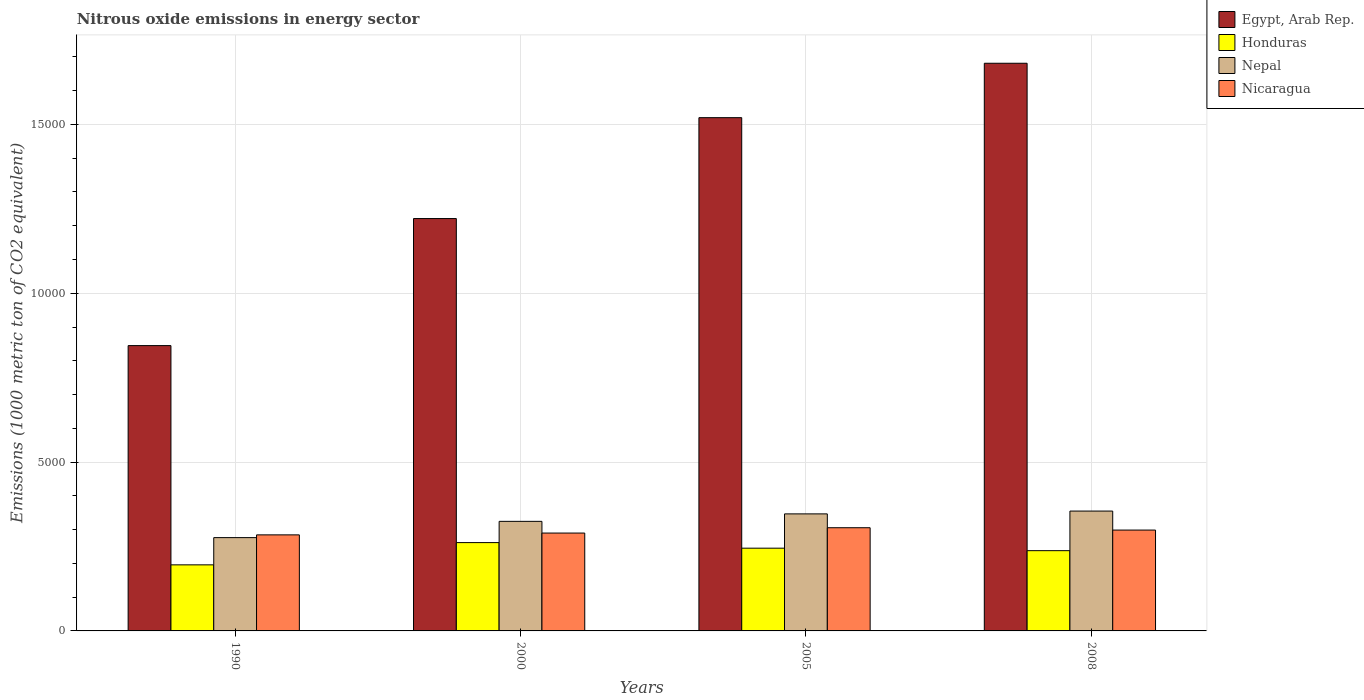Are the number of bars per tick equal to the number of legend labels?
Make the answer very short. Yes. Are the number of bars on each tick of the X-axis equal?
Offer a terse response. Yes. How many bars are there on the 3rd tick from the left?
Your response must be concise. 4. How many bars are there on the 1st tick from the right?
Offer a terse response. 4. What is the label of the 3rd group of bars from the left?
Make the answer very short. 2005. What is the amount of nitrous oxide emitted in Honduras in 2008?
Provide a short and direct response. 2376.9. Across all years, what is the maximum amount of nitrous oxide emitted in Nicaragua?
Your answer should be very brief. 3056.1. Across all years, what is the minimum amount of nitrous oxide emitted in Nicaragua?
Your response must be concise. 2844.7. In which year was the amount of nitrous oxide emitted in Egypt, Arab Rep. maximum?
Your answer should be compact. 2008. In which year was the amount of nitrous oxide emitted in Nicaragua minimum?
Provide a short and direct response. 1990. What is the total amount of nitrous oxide emitted in Nepal in the graph?
Offer a very short reply. 1.30e+04. What is the difference between the amount of nitrous oxide emitted in Honduras in 1990 and that in 2000?
Provide a succinct answer. -658.9. What is the difference between the amount of nitrous oxide emitted in Honduras in 2000 and the amount of nitrous oxide emitted in Nepal in 2008?
Give a very brief answer. -934. What is the average amount of nitrous oxide emitted in Honduras per year?
Your answer should be compact. 2349.78. In the year 2005, what is the difference between the amount of nitrous oxide emitted in Honduras and amount of nitrous oxide emitted in Nicaragua?
Provide a succinct answer. -605.8. In how many years, is the amount of nitrous oxide emitted in Honduras greater than 14000 1000 metric ton?
Offer a terse response. 0. What is the ratio of the amount of nitrous oxide emitted in Egypt, Arab Rep. in 2000 to that in 2005?
Provide a short and direct response. 0.8. Is the amount of nitrous oxide emitted in Honduras in 2000 less than that in 2005?
Give a very brief answer. No. What is the difference between the highest and the second highest amount of nitrous oxide emitted in Honduras?
Your answer should be compact. 165.1. What is the difference between the highest and the lowest amount of nitrous oxide emitted in Honduras?
Make the answer very short. 658.9. In how many years, is the amount of nitrous oxide emitted in Nepal greater than the average amount of nitrous oxide emitted in Nepal taken over all years?
Your answer should be very brief. 2. Is the sum of the amount of nitrous oxide emitted in Nepal in 1990 and 2000 greater than the maximum amount of nitrous oxide emitted in Nicaragua across all years?
Your answer should be very brief. Yes. What does the 3rd bar from the left in 1990 represents?
Provide a short and direct response. Nepal. What does the 4th bar from the right in 2008 represents?
Your answer should be compact. Egypt, Arab Rep. Is it the case that in every year, the sum of the amount of nitrous oxide emitted in Nicaragua and amount of nitrous oxide emitted in Egypt, Arab Rep. is greater than the amount of nitrous oxide emitted in Nepal?
Your response must be concise. Yes. Are all the bars in the graph horizontal?
Your response must be concise. No. How many years are there in the graph?
Your response must be concise. 4. What is the difference between two consecutive major ticks on the Y-axis?
Make the answer very short. 5000. Are the values on the major ticks of Y-axis written in scientific E-notation?
Make the answer very short. No. Where does the legend appear in the graph?
Make the answer very short. Top right. How many legend labels are there?
Offer a terse response. 4. What is the title of the graph?
Keep it short and to the point. Nitrous oxide emissions in energy sector. What is the label or title of the X-axis?
Keep it short and to the point. Years. What is the label or title of the Y-axis?
Provide a short and direct response. Emissions (1000 metric ton of CO2 equivalent). What is the Emissions (1000 metric ton of CO2 equivalent) in Egypt, Arab Rep. in 1990?
Your answer should be very brief. 8449.9. What is the Emissions (1000 metric ton of CO2 equivalent) in Honduras in 1990?
Your answer should be compact. 1956.5. What is the Emissions (1000 metric ton of CO2 equivalent) in Nepal in 1990?
Ensure brevity in your answer.  2763. What is the Emissions (1000 metric ton of CO2 equivalent) of Nicaragua in 1990?
Ensure brevity in your answer.  2844.7. What is the Emissions (1000 metric ton of CO2 equivalent) of Egypt, Arab Rep. in 2000?
Provide a succinct answer. 1.22e+04. What is the Emissions (1000 metric ton of CO2 equivalent) in Honduras in 2000?
Give a very brief answer. 2615.4. What is the Emissions (1000 metric ton of CO2 equivalent) of Nepal in 2000?
Make the answer very short. 3244.8. What is the Emissions (1000 metric ton of CO2 equivalent) in Nicaragua in 2000?
Provide a succinct answer. 2898.2. What is the Emissions (1000 metric ton of CO2 equivalent) in Egypt, Arab Rep. in 2005?
Your answer should be compact. 1.52e+04. What is the Emissions (1000 metric ton of CO2 equivalent) of Honduras in 2005?
Offer a terse response. 2450.3. What is the Emissions (1000 metric ton of CO2 equivalent) in Nepal in 2005?
Offer a terse response. 3466.2. What is the Emissions (1000 metric ton of CO2 equivalent) in Nicaragua in 2005?
Your answer should be very brief. 3056.1. What is the Emissions (1000 metric ton of CO2 equivalent) in Egypt, Arab Rep. in 2008?
Your answer should be very brief. 1.68e+04. What is the Emissions (1000 metric ton of CO2 equivalent) of Honduras in 2008?
Ensure brevity in your answer.  2376.9. What is the Emissions (1000 metric ton of CO2 equivalent) of Nepal in 2008?
Ensure brevity in your answer.  3549.4. What is the Emissions (1000 metric ton of CO2 equivalent) in Nicaragua in 2008?
Ensure brevity in your answer.  2986.9. Across all years, what is the maximum Emissions (1000 metric ton of CO2 equivalent) of Egypt, Arab Rep.?
Your response must be concise. 1.68e+04. Across all years, what is the maximum Emissions (1000 metric ton of CO2 equivalent) in Honduras?
Give a very brief answer. 2615.4. Across all years, what is the maximum Emissions (1000 metric ton of CO2 equivalent) of Nepal?
Make the answer very short. 3549.4. Across all years, what is the maximum Emissions (1000 metric ton of CO2 equivalent) of Nicaragua?
Offer a very short reply. 3056.1. Across all years, what is the minimum Emissions (1000 metric ton of CO2 equivalent) in Egypt, Arab Rep.?
Ensure brevity in your answer.  8449.9. Across all years, what is the minimum Emissions (1000 metric ton of CO2 equivalent) in Honduras?
Your answer should be compact. 1956.5. Across all years, what is the minimum Emissions (1000 metric ton of CO2 equivalent) of Nepal?
Offer a very short reply. 2763. Across all years, what is the minimum Emissions (1000 metric ton of CO2 equivalent) in Nicaragua?
Offer a terse response. 2844.7. What is the total Emissions (1000 metric ton of CO2 equivalent) in Egypt, Arab Rep. in the graph?
Provide a succinct answer. 5.27e+04. What is the total Emissions (1000 metric ton of CO2 equivalent) of Honduras in the graph?
Give a very brief answer. 9399.1. What is the total Emissions (1000 metric ton of CO2 equivalent) in Nepal in the graph?
Offer a very short reply. 1.30e+04. What is the total Emissions (1000 metric ton of CO2 equivalent) in Nicaragua in the graph?
Give a very brief answer. 1.18e+04. What is the difference between the Emissions (1000 metric ton of CO2 equivalent) of Egypt, Arab Rep. in 1990 and that in 2000?
Provide a short and direct response. -3762.5. What is the difference between the Emissions (1000 metric ton of CO2 equivalent) of Honduras in 1990 and that in 2000?
Give a very brief answer. -658.9. What is the difference between the Emissions (1000 metric ton of CO2 equivalent) of Nepal in 1990 and that in 2000?
Your answer should be very brief. -481.8. What is the difference between the Emissions (1000 metric ton of CO2 equivalent) of Nicaragua in 1990 and that in 2000?
Give a very brief answer. -53.5. What is the difference between the Emissions (1000 metric ton of CO2 equivalent) in Egypt, Arab Rep. in 1990 and that in 2005?
Your response must be concise. -6750.1. What is the difference between the Emissions (1000 metric ton of CO2 equivalent) in Honduras in 1990 and that in 2005?
Keep it short and to the point. -493.8. What is the difference between the Emissions (1000 metric ton of CO2 equivalent) of Nepal in 1990 and that in 2005?
Offer a terse response. -703.2. What is the difference between the Emissions (1000 metric ton of CO2 equivalent) in Nicaragua in 1990 and that in 2005?
Keep it short and to the point. -211.4. What is the difference between the Emissions (1000 metric ton of CO2 equivalent) in Egypt, Arab Rep. in 1990 and that in 2008?
Provide a short and direct response. -8361.5. What is the difference between the Emissions (1000 metric ton of CO2 equivalent) in Honduras in 1990 and that in 2008?
Offer a terse response. -420.4. What is the difference between the Emissions (1000 metric ton of CO2 equivalent) of Nepal in 1990 and that in 2008?
Provide a succinct answer. -786.4. What is the difference between the Emissions (1000 metric ton of CO2 equivalent) in Nicaragua in 1990 and that in 2008?
Ensure brevity in your answer.  -142.2. What is the difference between the Emissions (1000 metric ton of CO2 equivalent) of Egypt, Arab Rep. in 2000 and that in 2005?
Give a very brief answer. -2987.6. What is the difference between the Emissions (1000 metric ton of CO2 equivalent) of Honduras in 2000 and that in 2005?
Give a very brief answer. 165.1. What is the difference between the Emissions (1000 metric ton of CO2 equivalent) in Nepal in 2000 and that in 2005?
Ensure brevity in your answer.  -221.4. What is the difference between the Emissions (1000 metric ton of CO2 equivalent) in Nicaragua in 2000 and that in 2005?
Your answer should be very brief. -157.9. What is the difference between the Emissions (1000 metric ton of CO2 equivalent) of Egypt, Arab Rep. in 2000 and that in 2008?
Offer a terse response. -4599. What is the difference between the Emissions (1000 metric ton of CO2 equivalent) in Honduras in 2000 and that in 2008?
Offer a very short reply. 238.5. What is the difference between the Emissions (1000 metric ton of CO2 equivalent) in Nepal in 2000 and that in 2008?
Your answer should be very brief. -304.6. What is the difference between the Emissions (1000 metric ton of CO2 equivalent) in Nicaragua in 2000 and that in 2008?
Offer a terse response. -88.7. What is the difference between the Emissions (1000 metric ton of CO2 equivalent) of Egypt, Arab Rep. in 2005 and that in 2008?
Provide a succinct answer. -1611.4. What is the difference between the Emissions (1000 metric ton of CO2 equivalent) in Honduras in 2005 and that in 2008?
Your answer should be compact. 73.4. What is the difference between the Emissions (1000 metric ton of CO2 equivalent) of Nepal in 2005 and that in 2008?
Offer a very short reply. -83.2. What is the difference between the Emissions (1000 metric ton of CO2 equivalent) of Nicaragua in 2005 and that in 2008?
Ensure brevity in your answer.  69.2. What is the difference between the Emissions (1000 metric ton of CO2 equivalent) of Egypt, Arab Rep. in 1990 and the Emissions (1000 metric ton of CO2 equivalent) of Honduras in 2000?
Keep it short and to the point. 5834.5. What is the difference between the Emissions (1000 metric ton of CO2 equivalent) of Egypt, Arab Rep. in 1990 and the Emissions (1000 metric ton of CO2 equivalent) of Nepal in 2000?
Make the answer very short. 5205.1. What is the difference between the Emissions (1000 metric ton of CO2 equivalent) of Egypt, Arab Rep. in 1990 and the Emissions (1000 metric ton of CO2 equivalent) of Nicaragua in 2000?
Ensure brevity in your answer.  5551.7. What is the difference between the Emissions (1000 metric ton of CO2 equivalent) in Honduras in 1990 and the Emissions (1000 metric ton of CO2 equivalent) in Nepal in 2000?
Provide a short and direct response. -1288.3. What is the difference between the Emissions (1000 metric ton of CO2 equivalent) in Honduras in 1990 and the Emissions (1000 metric ton of CO2 equivalent) in Nicaragua in 2000?
Offer a terse response. -941.7. What is the difference between the Emissions (1000 metric ton of CO2 equivalent) in Nepal in 1990 and the Emissions (1000 metric ton of CO2 equivalent) in Nicaragua in 2000?
Offer a terse response. -135.2. What is the difference between the Emissions (1000 metric ton of CO2 equivalent) of Egypt, Arab Rep. in 1990 and the Emissions (1000 metric ton of CO2 equivalent) of Honduras in 2005?
Keep it short and to the point. 5999.6. What is the difference between the Emissions (1000 metric ton of CO2 equivalent) in Egypt, Arab Rep. in 1990 and the Emissions (1000 metric ton of CO2 equivalent) in Nepal in 2005?
Offer a very short reply. 4983.7. What is the difference between the Emissions (1000 metric ton of CO2 equivalent) in Egypt, Arab Rep. in 1990 and the Emissions (1000 metric ton of CO2 equivalent) in Nicaragua in 2005?
Offer a very short reply. 5393.8. What is the difference between the Emissions (1000 metric ton of CO2 equivalent) of Honduras in 1990 and the Emissions (1000 metric ton of CO2 equivalent) of Nepal in 2005?
Your response must be concise. -1509.7. What is the difference between the Emissions (1000 metric ton of CO2 equivalent) in Honduras in 1990 and the Emissions (1000 metric ton of CO2 equivalent) in Nicaragua in 2005?
Keep it short and to the point. -1099.6. What is the difference between the Emissions (1000 metric ton of CO2 equivalent) in Nepal in 1990 and the Emissions (1000 metric ton of CO2 equivalent) in Nicaragua in 2005?
Make the answer very short. -293.1. What is the difference between the Emissions (1000 metric ton of CO2 equivalent) in Egypt, Arab Rep. in 1990 and the Emissions (1000 metric ton of CO2 equivalent) in Honduras in 2008?
Your response must be concise. 6073. What is the difference between the Emissions (1000 metric ton of CO2 equivalent) in Egypt, Arab Rep. in 1990 and the Emissions (1000 metric ton of CO2 equivalent) in Nepal in 2008?
Make the answer very short. 4900.5. What is the difference between the Emissions (1000 metric ton of CO2 equivalent) in Egypt, Arab Rep. in 1990 and the Emissions (1000 metric ton of CO2 equivalent) in Nicaragua in 2008?
Your response must be concise. 5463. What is the difference between the Emissions (1000 metric ton of CO2 equivalent) of Honduras in 1990 and the Emissions (1000 metric ton of CO2 equivalent) of Nepal in 2008?
Ensure brevity in your answer.  -1592.9. What is the difference between the Emissions (1000 metric ton of CO2 equivalent) of Honduras in 1990 and the Emissions (1000 metric ton of CO2 equivalent) of Nicaragua in 2008?
Keep it short and to the point. -1030.4. What is the difference between the Emissions (1000 metric ton of CO2 equivalent) in Nepal in 1990 and the Emissions (1000 metric ton of CO2 equivalent) in Nicaragua in 2008?
Make the answer very short. -223.9. What is the difference between the Emissions (1000 metric ton of CO2 equivalent) of Egypt, Arab Rep. in 2000 and the Emissions (1000 metric ton of CO2 equivalent) of Honduras in 2005?
Your answer should be compact. 9762.1. What is the difference between the Emissions (1000 metric ton of CO2 equivalent) of Egypt, Arab Rep. in 2000 and the Emissions (1000 metric ton of CO2 equivalent) of Nepal in 2005?
Your answer should be compact. 8746.2. What is the difference between the Emissions (1000 metric ton of CO2 equivalent) of Egypt, Arab Rep. in 2000 and the Emissions (1000 metric ton of CO2 equivalent) of Nicaragua in 2005?
Provide a short and direct response. 9156.3. What is the difference between the Emissions (1000 metric ton of CO2 equivalent) of Honduras in 2000 and the Emissions (1000 metric ton of CO2 equivalent) of Nepal in 2005?
Provide a short and direct response. -850.8. What is the difference between the Emissions (1000 metric ton of CO2 equivalent) of Honduras in 2000 and the Emissions (1000 metric ton of CO2 equivalent) of Nicaragua in 2005?
Make the answer very short. -440.7. What is the difference between the Emissions (1000 metric ton of CO2 equivalent) in Nepal in 2000 and the Emissions (1000 metric ton of CO2 equivalent) in Nicaragua in 2005?
Offer a very short reply. 188.7. What is the difference between the Emissions (1000 metric ton of CO2 equivalent) of Egypt, Arab Rep. in 2000 and the Emissions (1000 metric ton of CO2 equivalent) of Honduras in 2008?
Offer a very short reply. 9835.5. What is the difference between the Emissions (1000 metric ton of CO2 equivalent) in Egypt, Arab Rep. in 2000 and the Emissions (1000 metric ton of CO2 equivalent) in Nepal in 2008?
Ensure brevity in your answer.  8663. What is the difference between the Emissions (1000 metric ton of CO2 equivalent) in Egypt, Arab Rep. in 2000 and the Emissions (1000 metric ton of CO2 equivalent) in Nicaragua in 2008?
Your response must be concise. 9225.5. What is the difference between the Emissions (1000 metric ton of CO2 equivalent) of Honduras in 2000 and the Emissions (1000 metric ton of CO2 equivalent) of Nepal in 2008?
Keep it short and to the point. -934. What is the difference between the Emissions (1000 metric ton of CO2 equivalent) of Honduras in 2000 and the Emissions (1000 metric ton of CO2 equivalent) of Nicaragua in 2008?
Provide a succinct answer. -371.5. What is the difference between the Emissions (1000 metric ton of CO2 equivalent) of Nepal in 2000 and the Emissions (1000 metric ton of CO2 equivalent) of Nicaragua in 2008?
Provide a short and direct response. 257.9. What is the difference between the Emissions (1000 metric ton of CO2 equivalent) of Egypt, Arab Rep. in 2005 and the Emissions (1000 metric ton of CO2 equivalent) of Honduras in 2008?
Your answer should be very brief. 1.28e+04. What is the difference between the Emissions (1000 metric ton of CO2 equivalent) in Egypt, Arab Rep. in 2005 and the Emissions (1000 metric ton of CO2 equivalent) in Nepal in 2008?
Offer a terse response. 1.17e+04. What is the difference between the Emissions (1000 metric ton of CO2 equivalent) of Egypt, Arab Rep. in 2005 and the Emissions (1000 metric ton of CO2 equivalent) of Nicaragua in 2008?
Your answer should be very brief. 1.22e+04. What is the difference between the Emissions (1000 metric ton of CO2 equivalent) of Honduras in 2005 and the Emissions (1000 metric ton of CO2 equivalent) of Nepal in 2008?
Offer a very short reply. -1099.1. What is the difference between the Emissions (1000 metric ton of CO2 equivalent) of Honduras in 2005 and the Emissions (1000 metric ton of CO2 equivalent) of Nicaragua in 2008?
Your response must be concise. -536.6. What is the difference between the Emissions (1000 metric ton of CO2 equivalent) in Nepal in 2005 and the Emissions (1000 metric ton of CO2 equivalent) in Nicaragua in 2008?
Give a very brief answer. 479.3. What is the average Emissions (1000 metric ton of CO2 equivalent) of Egypt, Arab Rep. per year?
Offer a very short reply. 1.32e+04. What is the average Emissions (1000 metric ton of CO2 equivalent) in Honduras per year?
Ensure brevity in your answer.  2349.78. What is the average Emissions (1000 metric ton of CO2 equivalent) of Nepal per year?
Provide a short and direct response. 3255.85. What is the average Emissions (1000 metric ton of CO2 equivalent) of Nicaragua per year?
Give a very brief answer. 2946.47. In the year 1990, what is the difference between the Emissions (1000 metric ton of CO2 equivalent) in Egypt, Arab Rep. and Emissions (1000 metric ton of CO2 equivalent) in Honduras?
Offer a terse response. 6493.4. In the year 1990, what is the difference between the Emissions (1000 metric ton of CO2 equivalent) in Egypt, Arab Rep. and Emissions (1000 metric ton of CO2 equivalent) in Nepal?
Your answer should be compact. 5686.9. In the year 1990, what is the difference between the Emissions (1000 metric ton of CO2 equivalent) of Egypt, Arab Rep. and Emissions (1000 metric ton of CO2 equivalent) of Nicaragua?
Offer a terse response. 5605.2. In the year 1990, what is the difference between the Emissions (1000 metric ton of CO2 equivalent) in Honduras and Emissions (1000 metric ton of CO2 equivalent) in Nepal?
Ensure brevity in your answer.  -806.5. In the year 1990, what is the difference between the Emissions (1000 metric ton of CO2 equivalent) of Honduras and Emissions (1000 metric ton of CO2 equivalent) of Nicaragua?
Your response must be concise. -888.2. In the year 1990, what is the difference between the Emissions (1000 metric ton of CO2 equivalent) of Nepal and Emissions (1000 metric ton of CO2 equivalent) of Nicaragua?
Ensure brevity in your answer.  -81.7. In the year 2000, what is the difference between the Emissions (1000 metric ton of CO2 equivalent) of Egypt, Arab Rep. and Emissions (1000 metric ton of CO2 equivalent) of Honduras?
Your answer should be very brief. 9597. In the year 2000, what is the difference between the Emissions (1000 metric ton of CO2 equivalent) in Egypt, Arab Rep. and Emissions (1000 metric ton of CO2 equivalent) in Nepal?
Ensure brevity in your answer.  8967.6. In the year 2000, what is the difference between the Emissions (1000 metric ton of CO2 equivalent) in Egypt, Arab Rep. and Emissions (1000 metric ton of CO2 equivalent) in Nicaragua?
Keep it short and to the point. 9314.2. In the year 2000, what is the difference between the Emissions (1000 metric ton of CO2 equivalent) in Honduras and Emissions (1000 metric ton of CO2 equivalent) in Nepal?
Provide a short and direct response. -629.4. In the year 2000, what is the difference between the Emissions (1000 metric ton of CO2 equivalent) in Honduras and Emissions (1000 metric ton of CO2 equivalent) in Nicaragua?
Offer a terse response. -282.8. In the year 2000, what is the difference between the Emissions (1000 metric ton of CO2 equivalent) of Nepal and Emissions (1000 metric ton of CO2 equivalent) of Nicaragua?
Give a very brief answer. 346.6. In the year 2005, what is the difference between the Emissions (1000 metric ton of CO2 equivalent) in Egypt, Arab Rep. and Emissions (1000 metric ton of CO2 equivalent) in Honduras?
Give a very brief answer. 1.27e+04. In the year 2005, what is the difference between the Emissions (1000 metric ton of CO2 equivalent) of Egypt, Arab Rep. and Emissions (1000 metric ton of CO2 equivalent) of Nepal?
Your answer should be very brief. 1.17e+04. In the year 2005, what is the difference between the Emissions (1000 metric ton of CO2 equivalent) in Egypt, Arab Rep. and Emissions (1000 metric ton of CO2 equivalent) in Nicaragua?
Ensure brevity in your answer.  1.21e+04. In the year 2005, what is the difference between the Emissions (1000 metric ton of CO2 equivalent) of Honduras and Emissions (1000 metric ton of CO2 equivalent) of Nepal?
Offer a very short reply. -1015.9. In the year 2005, what is the difference between the Emissions (1000 metric ton of CO2 equivalent) of Honduras and Emissions (1000 metric ton of CO2 equivalent) of Nicaragua?
Provide a short and direct response. -605.8. In the year 2005, what is the difference between the Emissions (1000 metric ton of CO2 equivalent) of Nepal and Emissions (1000 metric ton of CO2 equivalent) of Nicaragua?
Your answer should be compact. 410.1. In the year 2008, what is the difference between the Emissions (1000 metric ton of CO2 equivalent) in Egypt, Arab Rep. and Emissions (1000 metric ton of CO2 equivalent) in Honduras?
Keep it short and to the point. 1.44e+04. In the year 2008, what is the difference between the Emissions (1000 metric ton of CO2 equivalent) of Egypt, Arab Rep. and Emissions (1000 metric ton of CO2 equivalent) of Nepal?
Give a very brief answer. 1.33e+04. In the year 2008, what is the difference between the Emissions (1000 metric ton of CO2 equivalent) in Egypt, Arab Rep. and Emissions (1000 metric ton of CO2 equivalent) in Nicaragua?
Ensure brevity in your answer.  1.38e+04. In the year 2008, what is the difference between the Emissions (1000 metric ton of CO2 equivalent) in Honduras and Emissions (1000 metric ton of CO2 equivalent) in Nepal?
Provide a short and direct response. -1172.5. In the year 2008, what is the difference between the Emissions (1000 metric ton of CO2 equivalent) in Honduras and Emissions (1000 metric ton of CO2 equivalent) in Nicaragua?
Offer a very short reply. -610. In the year 2008, what is the difference between the Emissions (1000 metric ton of CO2 equivalent) in Nepal and Emissions (1000 metric ton of CO2 equivalent) in Nicaragua?
Keep it short and to the point. 562.5. What is the ratio of the Emissions (1000 metric ton of CO2 equivalent) in Egypt, Arab Rep. in 1990 to that in 2000?
Keep it short and to the point. 0.69. What is the ratio of the Emissions (1000 metric ton of CO2 equivalent) of Honduras in 1990 to that in 2000?
Your answer should be very brief. 0.75. What is the ratio of the Emissions (1000 metric ton of CO2 equivalent) in Nepal in 1990 to that in 2000?
Your response must be concise. 0.85. What is the ratio of the Emissions (1000 metric ton of CO2 equivalent) of Nicaragua in 1990 to that in 2000?
Keep it short and to the point. 0.98. What is the ratio of the Emissions (1000 metric ton of CO2 equivalent) of Egypt, Arab Rep. in 1990 to that in 2005?
Make the answer very short. 0.56. What is the ratio of the Emissions (1000 metric ton of CO2 equivalent) of Honduras in 1990 to that in 2005?
Offer a very short reply. 0.8. What is the ratio of the Emissions (1000 metric ton of CO2 equivalent) of Nepal in 1990 to that in 2005?
Provide a succinct answer. 0.8. What is the ratio of the Emissions (1000 metric ton of CO2 equivalent) of Nicaragua in 1990 to that in 2005?
Make the answer very short. 0.93. What is the ratio of the Emissions (1000 metric ton of CO2 equivalent) of Egypt, Arab Rep. in 1990 to that in 2008?
Ensure brevity in your answer.  0.5. What is the ratio of the Emissions (1000 metric ton of CO2 equivalent) of Honduras in 1990 to that in 2008?
Offer a terse response. 0.82. What is the ratio of the Emissions (1000 metric ton of CO2 equivalent) of Nepal in 1990 to that in 2008?
Your response must be concise. 0.78. What is the ratio of the Emissions (1000 metric ton of CO2 equivalent) of Nicaragua in 1990 to that in 2008?
Keep it short and to the point. 0.95. What is the ratio of the Emissions (1000 metric ton of CO2 equivalent) in Egypt, Arab Rep. in 2000 to that in 2005?
Your answer should be compact. 0.8. What is the ratio of the Emissions (1000 metric ton of CO2 equivalent) of Honduras in 2000 to that in 2005?
Offer a terse response. 1.07. What is the ratio of the Emissions (1000 metric ton of CO2 equivalent) in Nepal in 2000 to that in 2005?
Your answer should be very brief. 0.94. What is the ratio of the Emissions (1000 metric ton of CO2 equivalent) in Nicaragua in 2000 to that in 2005?
Your answer should be compact. 0.95. What is the ratio of the Emissions (1000 metric ton of CO2 equivalent) in Egypt, Arab Rep. in 2000 to that in 2008?
Give a very brief answer. 0.73. What is the ratio of the Emissions (1000 metric ton of CO2 equivalent) in Honduras in 2000 to that in 2008?
Your answer should be very brief. 1.1. What is the ratio of the Emissions (1000 metric ton of CO2 equivalent) of Nepal in 2000 to that in 2008?
Your answer should be very brief. 0.91. What is the ratio of the Emissions (1000 metric ton of CO2 equivalent) of Nicaragua in 2000 to that in 2008?
Give a very brief answer. 0.97. What is the ratio of the Emissions (1000 metric ton of CO2 equivalent) of Egypt, Arab Rep. in 2005 to that in 2008?
Ensure brevity in your answer.  0.9. What is the ratio of the Emissions (1000 metric ton of CO2 equivalent) in Honduras in 2005 to that in 2008?
Give a very brief answer. 1.03. What is the ratio of the Emissions (1000 metric ton of CO2 equivalent) of Nepal in 2005 to that in 2008?
Make the answer very short. 0.98. What is the ratio of the Emissions (1000 metric ton of CO2 equivalent) in Nicaragua in 2005 to that in 2008?
Provide a succinct answer. 1.02. What is the difference between the highest and the second highest Emissions (1000 metric ton of CO2 equivalent) in Egypt, Arab Rep.?
Your response must be concise. 1611.4. What is the difference between the highest and the second highest Emissions (1000 metric ton of CO2 equivalent) of Honduras?
Your answer should be very brief. 165.1. What is the difference between the highest and the second highest Emissions (1000 metric ton of CO2 equivalent) in Nepal?
Make the answer very short. 83.2. What is the difference between the highest and the second highest Emissions (1000 metric ton of CO2 equivalent) in Nicaragua?
Provide a short and direct response. 69.2. What is the difference between the highest and the lowest Emissions (1000 metric ton of CO2 equivalent) in Egypt, Arab Rep.?
Your answer should be very brief. 8361.5. What is the difference between the highest and the lowest Emissions (1000 metric ton of CO2 equivalent) in Honduras?
Keep it short and to the point. 658.9. What is the difference between the highest and the lowest Emissions (1000 metric ton of CO2 equivalent) of Nepal?
Offer a terse response. 786.4. What is the difference between the highest and the lowest Emissions (1000 metric ton of CO2 equivalent) in Nicaragua?
Your answer should be compact. 211.4. 